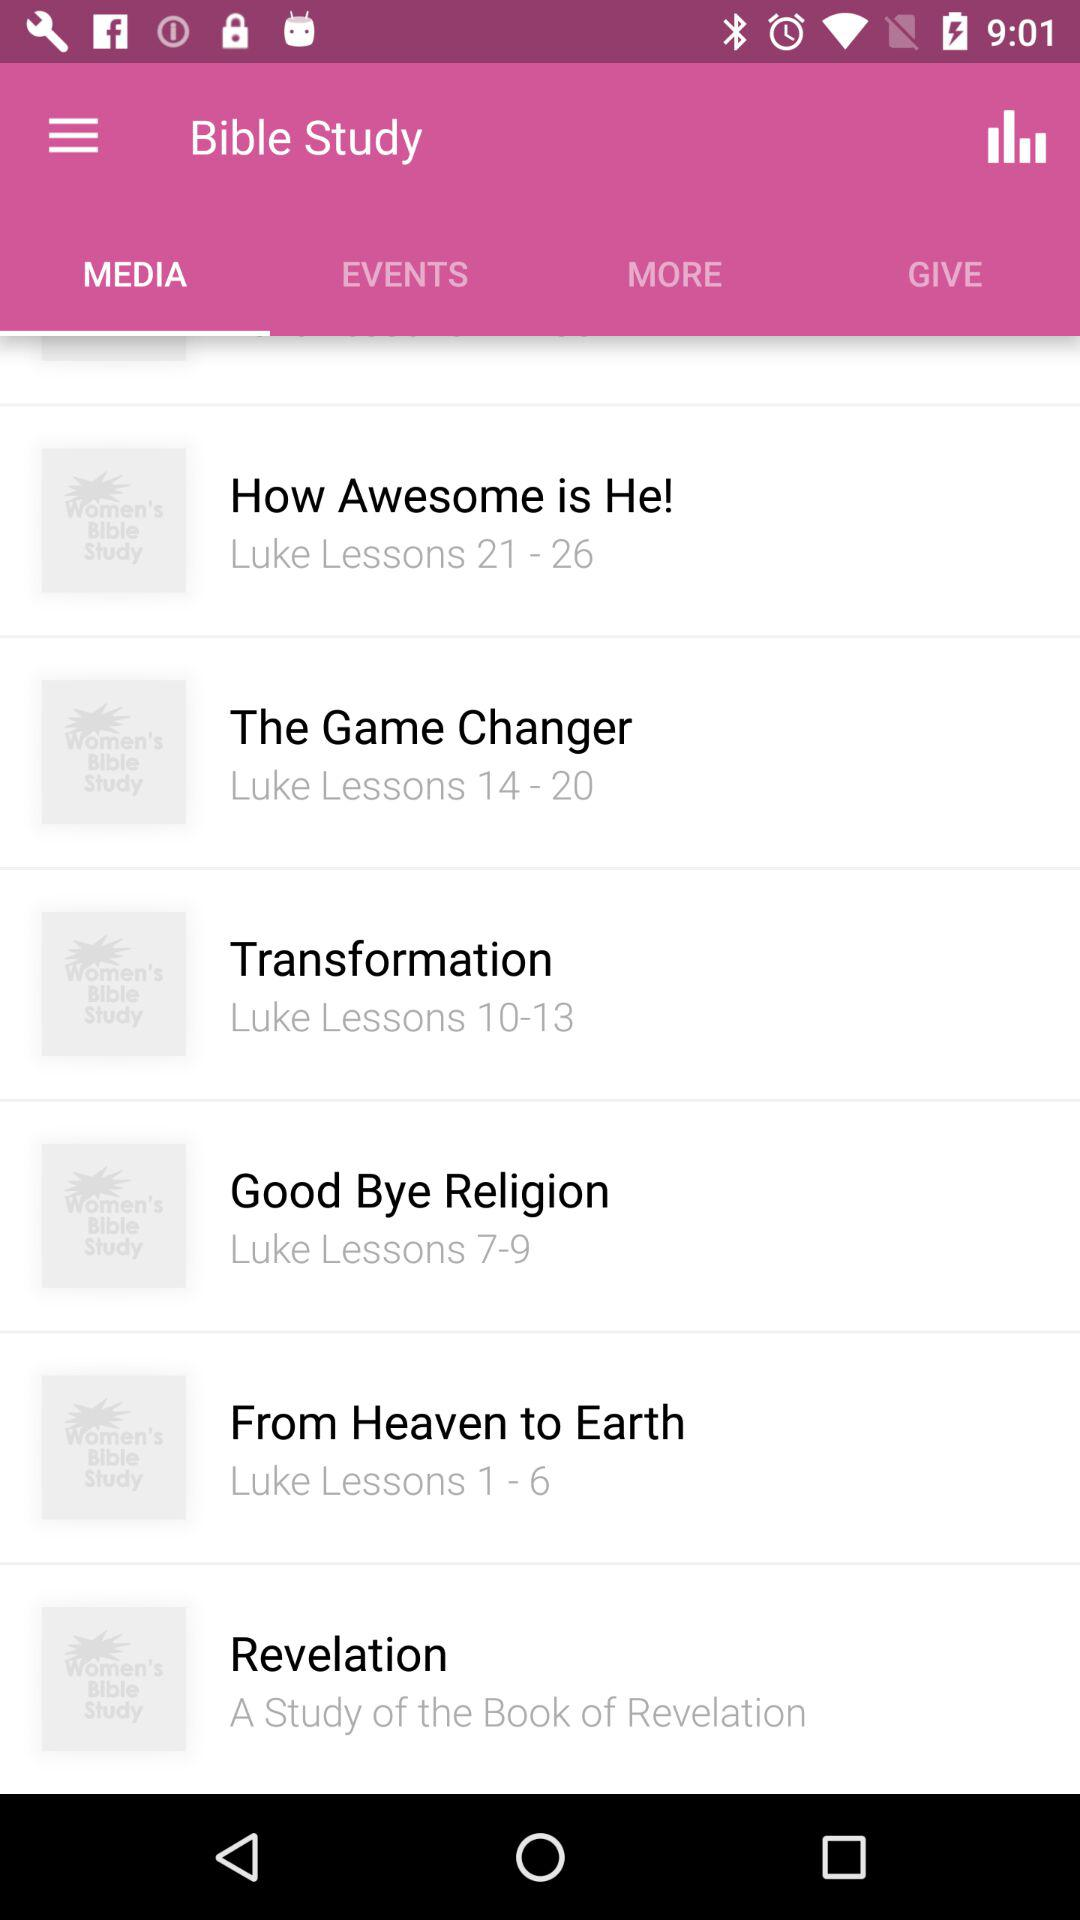What is the lessons' range in "The Game Changer"? The range is 14 to 20. 